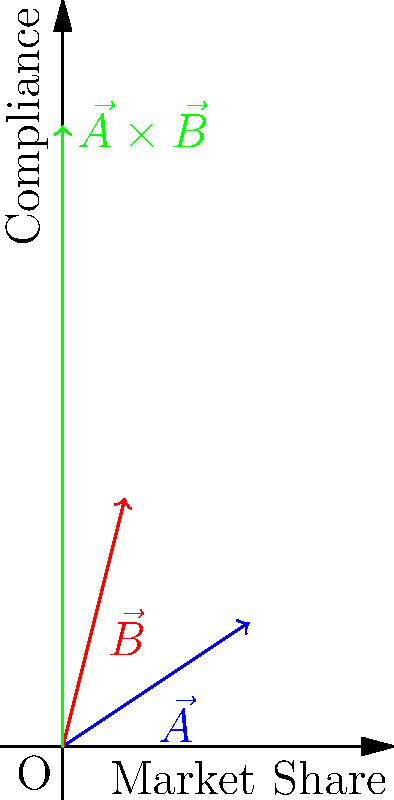Given two corporate strategy vectors $\vec{A}$ (blue) and $\vec{B}$ (red) in the graph, where the x-axis represents market share and the y-axis represents compliance, what does the magnitude of their cross product $\|\vec{A} \times \vec{B}\|$ (green) indicate in terms of policy adherence, and how should a legal advisor interpret this result? To interpret the cross product of two corporate strategy vectors in terms of policy adherence:

1. Recognize that $\vec{A}$ (3,2) represents a strategy favoring market share growth with moderate compliance, while $\vec{B}$ (1,4) prioritizes high compliance with minimal market share growth.

2. Calculate the magnitude of the cross product:
   $\|\vec{A} \times \vec{B}\| = |A_x B_y - A_y B_x| = |3(4) - 2(1)| = |12 - 2| = 10$

3. Interpret the result:
   a) The magnitude of the cross product represents the area of the parallelogram formed by the two vectors.
   b) A larger magnitude indicates a greater divergence between the strategies.
   c) In this case, the relatively large magnitude (10) suggests a significant difference in strategic approaches.

4. From a legal advisor's perspective:
   a) The large divergence indicates potential conflicts between market growth and compliance priorities.
   b) This necessitates careful policy review to ensure all strategies align with company rules.
   c) It may require developing new policies to bridge the gap between growth and compliance objectives.
   d) The legal advisor should recommend a balanced approach that maintains strict adherence to policies while allowing for strategic flexibility.

5. Action items for the legal advisor:
   a) Review existing policies to identify any areas of conflict between the strategies.
   b) Propose policy amendments or new policies to accommodate both strategic directions while ensuring compliance.
   c) Advise on potential legal risks associated with each strategy and suggest mitigation measures.
   d) Recommend regular strategy reviews to maintain alignment with company policies and rules.
Answer: The cross product magnitude indicates strategy divergence, requiring policy review and balanced approach to ensure compliance while accommodating growth objectives. 